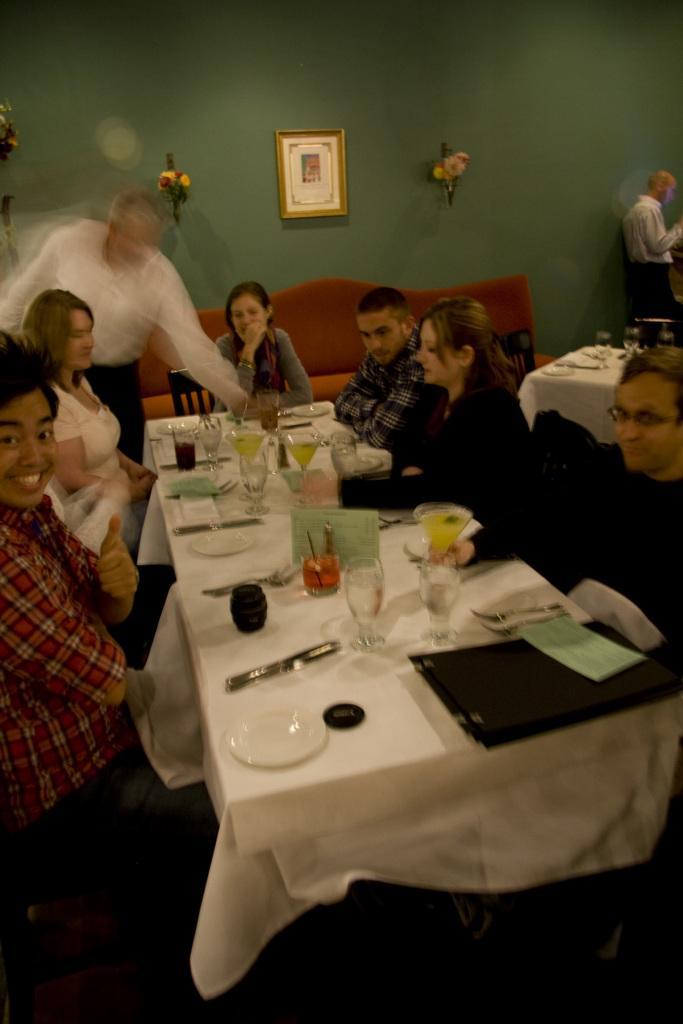Can you describe this image briefly? In this image i can see few persons sitting on a chair and a man standing there are few glasses, spoons, plate, paper on a table at the back ground i can see a table a man standing, a flower a frame on the wall. 